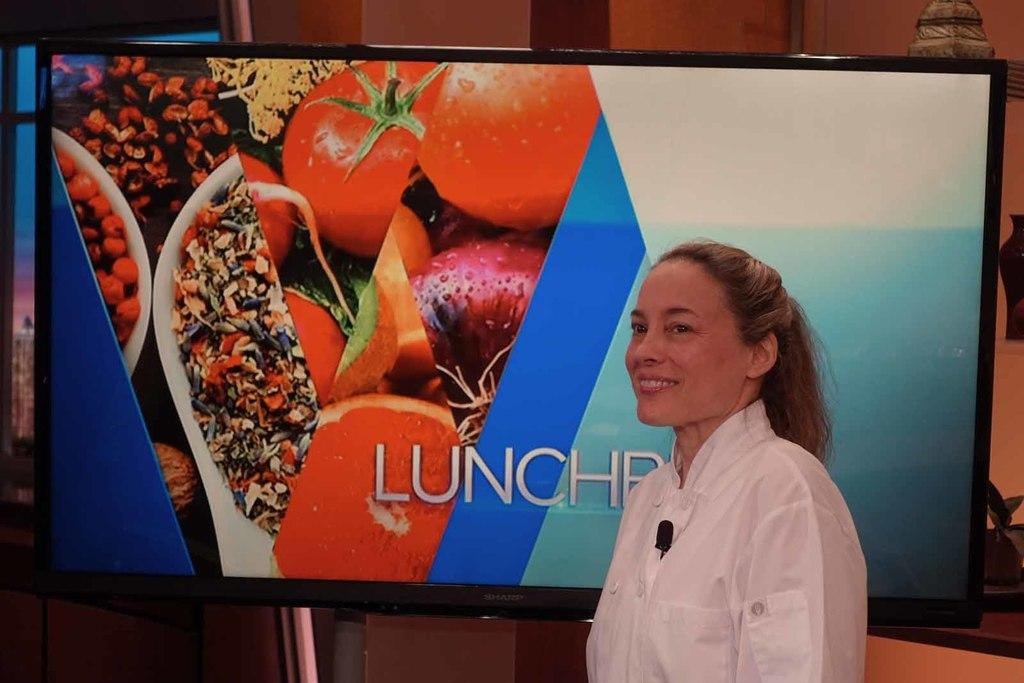What is the main subject of the image? There is a lady standing in the center of the image. Can you describe the background of the image? There is a TV screen in the background of the image. What type of soda is being advertised on the clock in the image? There is no clock or soda advertisement present in the image. 